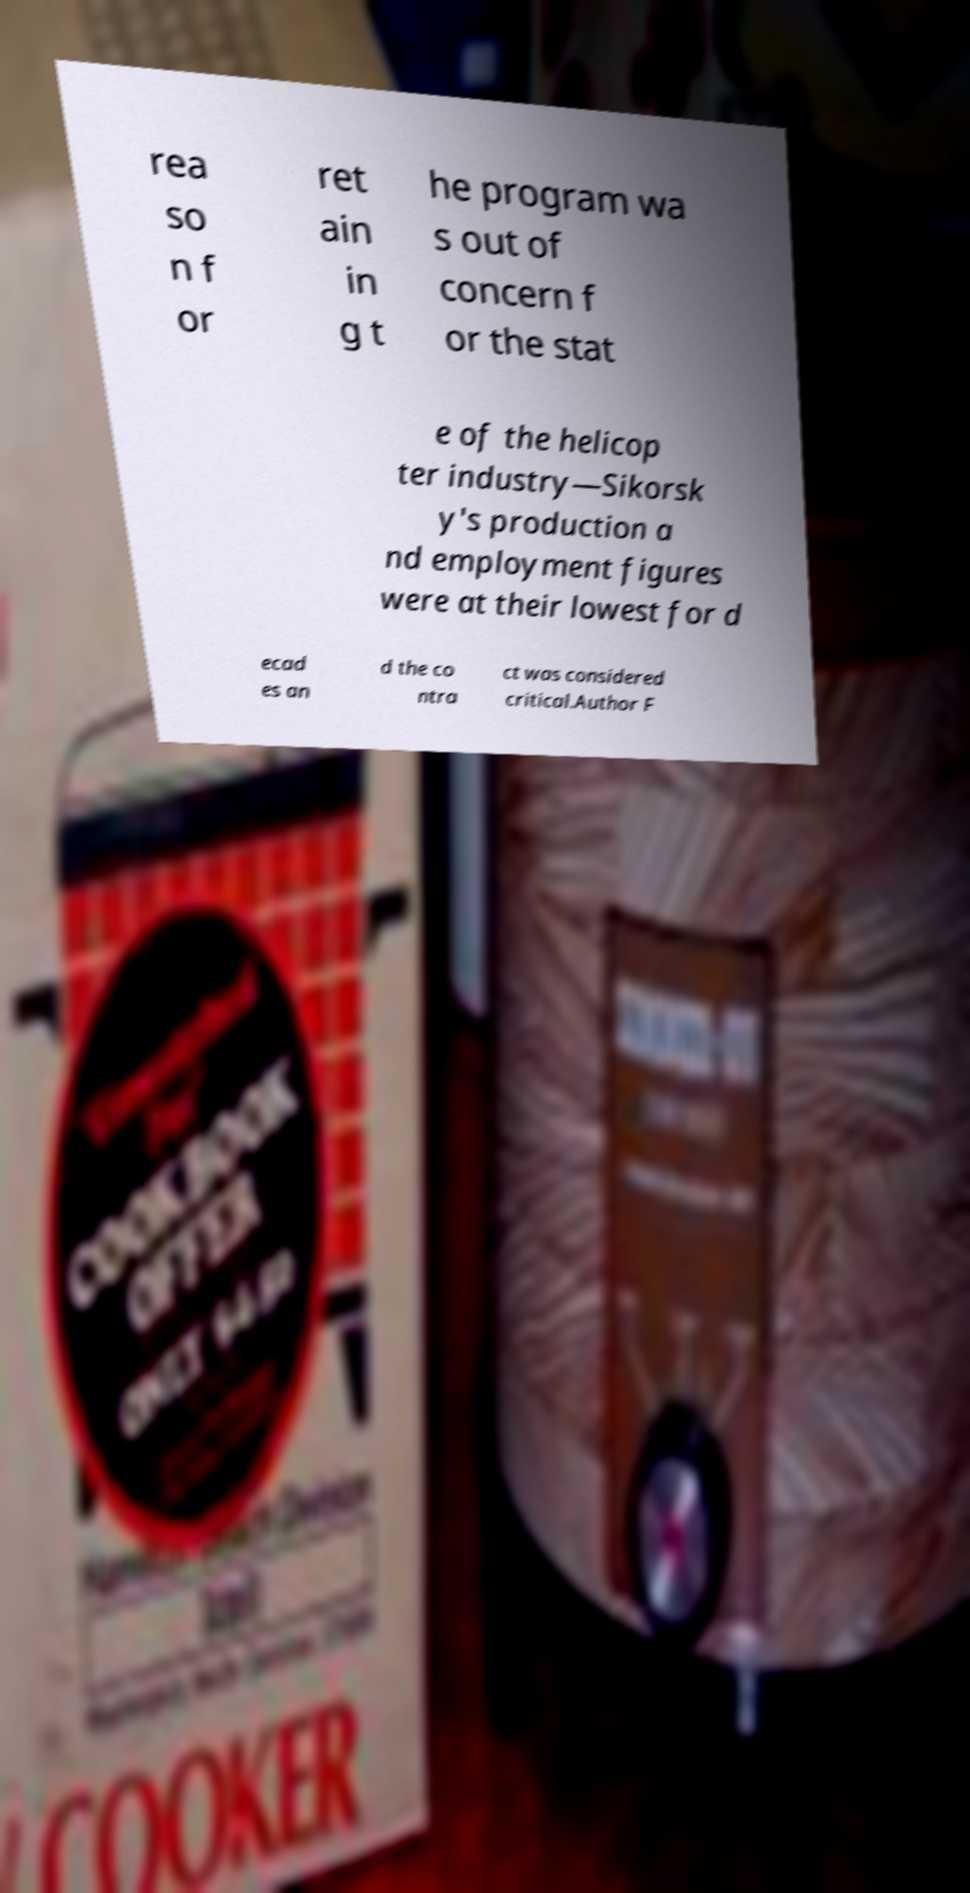Could you extract and type out the text from this image? rea so n f or ret ain in g t he program wa s out of concern f or the stat e of the helicop ter industry—Sikorsk y's production a nd employment figures were at their lowest for d ecad es an d the co ntra ct was considered critical.Author F 